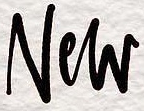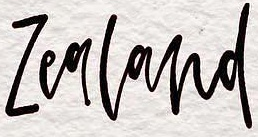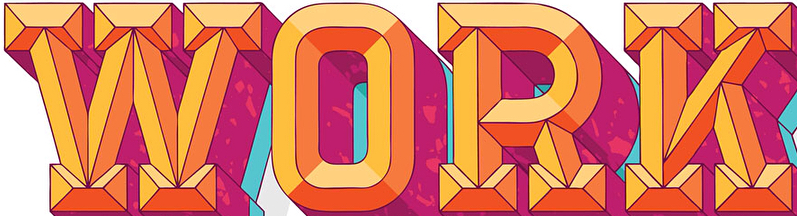What text appears in these images from left to right, separated by a semicolon? New; Zealand; WORK 